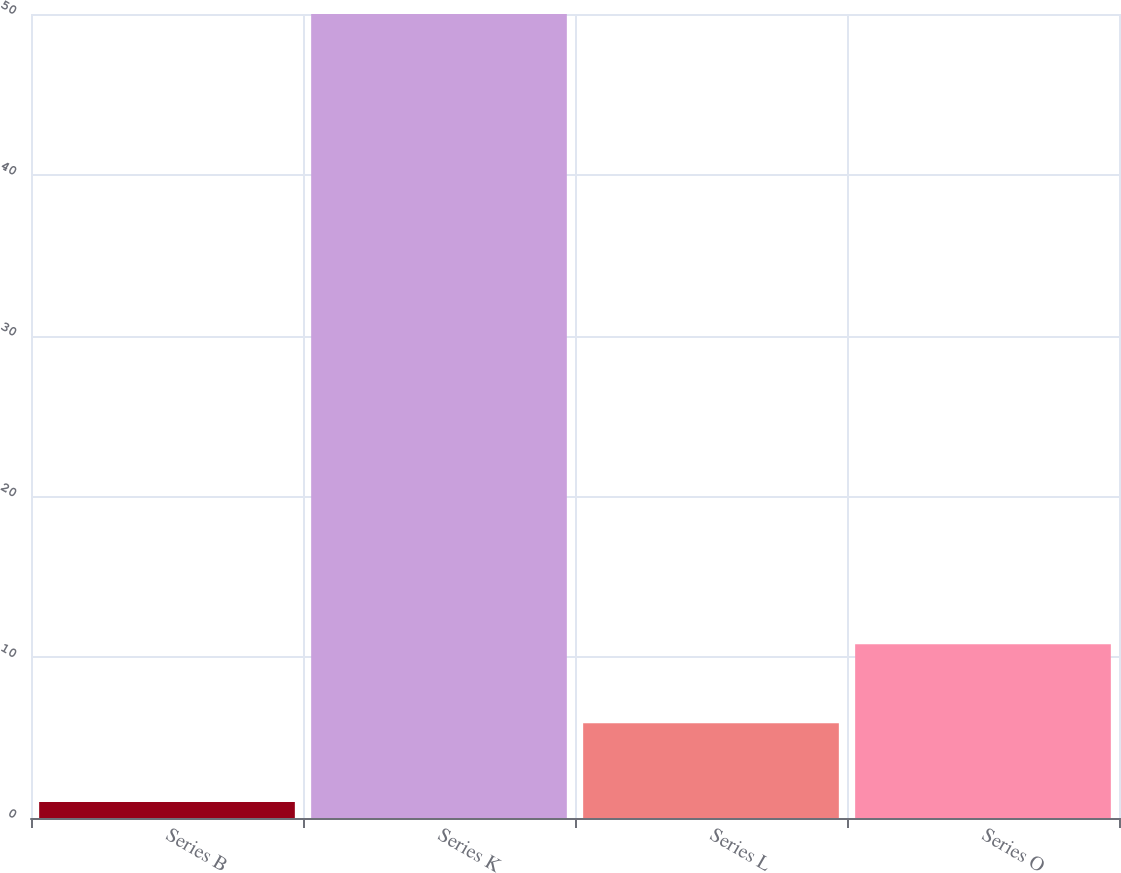Convert chart. <chart><loc_0><loc_0><loc_500><loc_500><bar_chart><fcel>Series B<fcel>Series K<fcel>Series L<fcel>Series O<nl><fcel>1<fcel>50<fcel>5.9<fcel>10.8<nl></chart> 